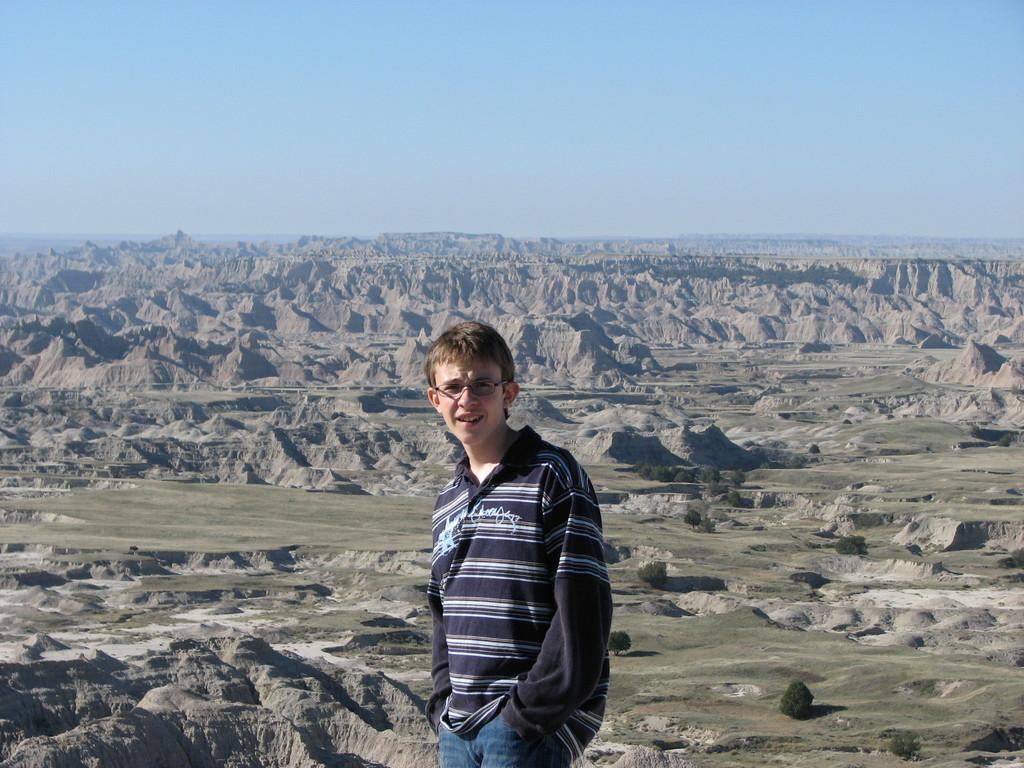Who is the main subject in the image? There is a boy in the image. What is the boy doing in the image? The boy is standing. What accessory is the boy wearing in the image? The boy is wearing glasses (specs) in the image. What can be seen in the background of the image? There are plants in the background of the image. What is the color of the sky in the image? The sky is visible at the top of the image and is blue. What type of soap is the boy holding in the image? There is no soap present in the image; the boy is wearing glasses and standing in front of plants. How many bites has the boy taken out of the plants in the image? The boy is not biting or eating any part of the plants in the image. 